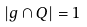<formula> <loc_0><loc_0><loc_500><loc_500>| g \cap Q | = 1</formula> 